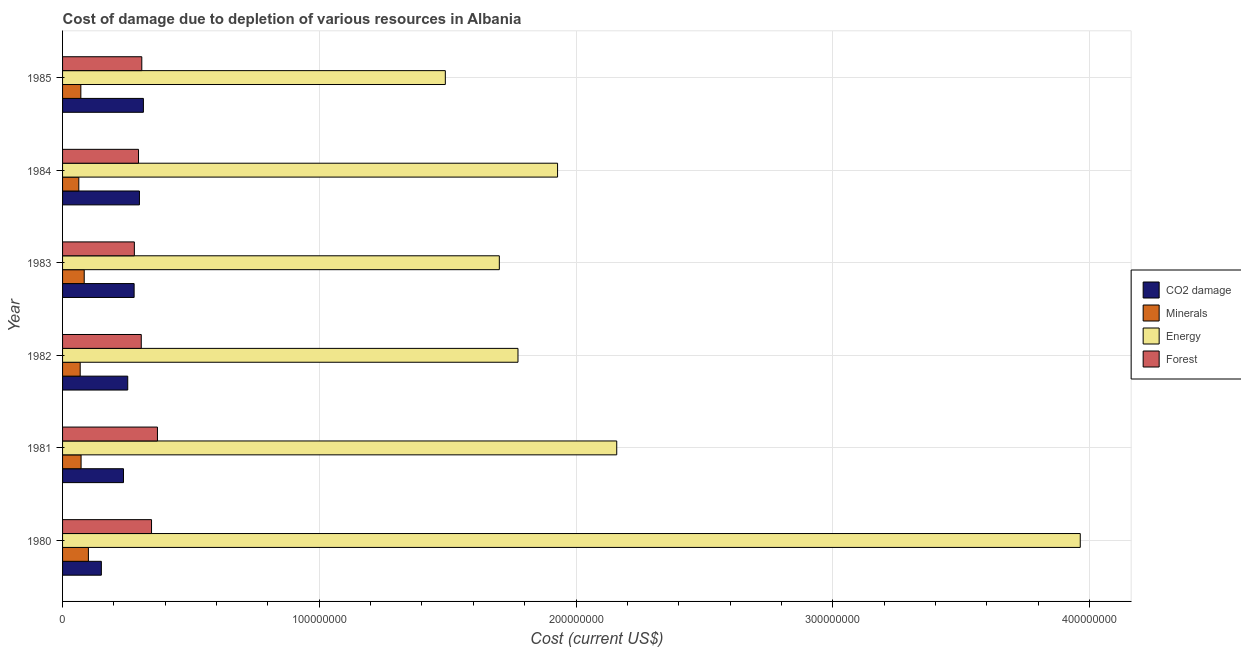Are the number of bars per tick equal to the number of legend labels?
Give a very brief answer. Yes. Are the number of bars on each tick of the Y-axis equal?
Give a very brief answer. Yes. In how many cases, is the number of bars for a given year not equal to the number of legend labels?
Give a very brief answer. 0. What is the cost of damage due to depletion of coal in 1981?
Ensure brevity in your answer.  2.37e+07. Across all years, what is the maximum cost of damage due to depletion of energy?
Keep it short and to the point. 3.96e+08. Across all years, what is the minimum cost of damage due to depletion of energy?
Provide a short and direct response. 1.49e+08. What is the total cost of damage due to depletion of energy in the graph?
Provide a succinct answer. 1.30e+09. What is the difference between the cost of damage due to depletion of forests in 1981 and that in 1985?
Provide a succinct answer. 6.10e+06. What is the difference between the cost of damage due to depletion of coal in 1980 and the cost of damage due to depletion of minerals in 1983?
Keep it short and to the point. 6.67e+06. What is the average cost of damage due to depletion of energy per year?
Your answer should be very brief. 2.17e+08. In the year 1982, what is the difference between the cost of damage due to depletion of coal and cost of damage due to depletion of forests?
Ensure brevity in your answer.  -5.27e+06. What is the ratio of the cost of damage due to depletion of minerals in 1980 to that in 1984?
Offer a terse response. 1.59. What is the difference between the highest and the second highest cost of damage due to depletion of coal?
Your answer should be compact. 1.54e+06. What is the difference between the highest and the lowest cost of damage due to depletion of energy?
Make the answer very short. 2.47e+08. In how many years, is the cost of damage due to depletion of forests greater than the average cost of damage due to depletion of forests taken over all years?
Provide a short and direct response. 2. Is the sum of the cost of damage due to depletion of forests in 1980 and 1982 greater than the maximum cost of damage due to depletion of coal across all years?
Make the answer very short. Yes. What does the 1st bar from the top in 1985 represents?
Your response must be concise. Forest. What does the 3rd bar from the bottom in 1985 represents?
Offer a very short reply. Energy. How many years are there in the graph?
Provide a succinct answer. 6. Does the graph contain grids?
Offer a very short reply. Yes. Where does the legend appear in the graph?
Offer a terse response. Center right. What is the title of the graph?
Offer a terse response. Cost of damage due to depletion of various resources in Albania . What is the label or title of the X-axis?
Offer a terse response. Cost (current US$). What is the label or title of the Y-axis?
Your answer should be compact. Year. What is the Cost (current US$) in CO2 damage in 1980?
Your answer should be very brief. 1.51e+07. What is the Cost (current US$) of Minerals in 1980?
Keep it short and to the point. 1.01e+07. What is the Cost (current US$) in Energy in 1980?
Make the answer very short. 3.96e+08. What is the Cost (current US$) in Forest in 1980?
Your answer should be compact. 3.47e+07. What is the Cost (current US$) in CO2 damage in 1981?
Give a very brief answer. 2.37e+07. What is the Cost (current US$) in Minerals in 1981?
Ensure brevity in your answer.  7.21e+06. What is the Cost (current US$) of Energy in 1981?
Your answer should be compact. 2.16e+08. What is the Cost (current US$) in Forest in 1981?
Your response must be concise. 3.70e+07. What is the Cost (current US$) of CO2 damage in 1982?
Keep it short and to the point. 2.54e+07. What is the Cost (current US$) of Minerals in 1982?
Offer a terse response. 6.87e+06. What is the Cost (current US$) in Energy in 1982?
Your response must be concise. 1.77e+08. What is the Cost (current US$) in Forest in 1982?
Offer a terse response. 3.07e+07. What is the Cost (current US$) of CO2 damage in 1983?
Provide a succinct answer. 2.79e+07. What is the Cost (current US$) of Minerals in 1983?
Give a very brief answer. 8.43e+06. What is the Cost (current US$) in Energy in 1983?
Make the answer very short. 1.70e+08. What is the Cost (current US$) in Forest in 1983?
Make the answer very short. 2.80e+07. What is the Cost (current US$) in CO2 damage in 1984?
Offer a terse response. 2.99e+07. What is the Cost (current US$) in Minerals in 1984?
Your response must be concise. 6.33e+06. What is the Cost (current US$) of Energy in 1984?
Make the answer very short. 1.93e+08. What is the Cost (current US$) in Forest in 1984?
Give a very brief answer. 2.96e+07. What is the Cost (current US$) of CO2 damage in 1985?
Give a very brief answer. 3.15e+07. What is the Cost (current US$) of Minerals in 1985?
Your answer should be compact. 7.12e+06. What is the Cost (current US$) in Energy in 1985?
Offer a terse response. 1.49e+08. What is the Cost (current US$) in Forest in 1985?
Provide a succinct answer. 3.09e+07. Across all years, what is the maximum Cost (current US$) in CO2 damage?
Keep it short and to the point. 3.15e+07. Across all years, what is the maximum Cost (current US$) in Minerals?
Offer a terse response. 1.01e+07. Across all years, what is the maximum Cost (current US$) of Energy?
Your answer should be very brief. 3.96e+08. Across all years, what is the maximum Cost (current US$) in Forest?
Ensure brevity in your answer.  3.70e+07. Across all years, what is the minimum Cost (current US$) of CO2 damage?
Your answer should be compact. 1.51e+07. Across all years, what is the minimum Cost (current US$) of Minerals?
Provide a short and direct response. 6.33e+06. Across all years, what is the minimum Cost (current US$) of Energy?
Your answer should be very brief. 1.49e+08. Across all years, what is the minimum Cost (current US$) in Forest?
Provide a succinct answer. 2.80e+07. What is the total Cost (current US$) of CO2 damage in the graph?
Your answer should be compact. 1.54e+08. What is the total Cost (current US$) in Minerals in the graph?
Keep it short and to the point. 4.60e+07. What is the total Cost (current US$) in Energy in the graph?
Your response must be concise. 1.30e+09. What is the total Cost (current US$) in Forest in the graph?
Your response must be concise. 1.91e+08. What is the difference between the Cost (current US$) in CO2 damage in 1980 and that in 1981?
Provide a succinct answer. -8.62e+06. What is the difference between the Cost (current US$) in Minerals in 1980 and that in 1981?
Keep it short and to the point. 2.86e+06. What is the difference between the Cost (current US$) of Energy in 1980 and that in 1981?
Keep it short and to the point. 1.81e+08. What is the difference between the Cost (current US$) in Forest in 1980 and that in 1981?
Give a very brief answer. -2.31e+06. What is the difference between the Cost (current US$) in CO2 damage in 1980 and that in 1982?
Your answer should be very brief. -1.03e+07. What is the difference between the Cost (current US$) of Minerals in 1980 and that in 1982?
Make the answer very short. 3.20e+06. What is the difference between the Cost (current US$) of Energy in 1980 and that in 1982?
Your answer should be very brief. 2.19e+08. What is the difference between the Cost (current US$) of Forest in 1980 and that in 1982?
Your answer should be compact. 4.00e+06. What is the difference between the Cost (current US$) in CO2 damage in 1980 and that in 1983?
Provide a succinct answer. -1.28e+07. What is the difference between the Cost (current US$) in Minerals in 1980 and that in 1983?
Offer a very short reply. 1.63e+06. What is the difference between the Cost (current US$) in Energy in 1980 and that in 1983?
Keep it short and to the point. 2.26e+08. What is the difference between the Cost (current US$) of Forest in 1980 and that in 1983?
Offer a very short reply. 6.68e+06. What is the difference between the Cost (current US$) of CO2 damage in 1980 and that in 1984?
Your answer should be very brief. -1.48e+07. What is the difference between the Cost (current US$) in Minerals in 1980 and that in 1984?
Ensure brevity in your answer.  3.74e+06. What is the difference between the Cost (current US$) in Energy in 1980 and that in 1984?
Offer a terse response. 2.04e+08. What is the difference between the Cost (current US$) of Forest in 1980 and that in 1984?
Make the answer very short. 5.07e+06. What is the difference between the Cost (current US$) in CO2 damage in 1980 and that in 1985?
Provide a succinct answer. -1.64e+07. What is the difference between the Cost (current US$) of Minerals in 1980 and that in 1985?
Provide a short and direct response. 2.95e+06. What is the difference between the Cost (current US$) of Energy in 1980 and that in 1985?
Provide a succinct answer. 2.47e+08. What is the difference between the Cost (current US$) of Forest in 1980 and that in 1985?
Provide a succinct answer. 3.79e+06. What is the difference between the Cost (current US$) in CO2 damage in 1981 and that in 1982?
Your answer should be very brief. -1.65e+06. What is the difference between the Cost (current US$) of Minerals in 1981 and that in 1982?
Offer a terse response. 3.46e+05. What is the difference between the Cost (current US$) of Energy in 1981 and that in 1982?
Your response must be concise. 3.85e+07. What is the difference between the Cost (current US$) of Forest in 1981 and that in 1982?
Ensure brevity in your answer.  6.31e+06. What is the difference between the Cost (current US$) of CO2 damage in 1981 and that in 1983?
Your answer should be compact. -4.14e+06. What is the difference between the Cost (current US$) of Minerals in 1981 and that in 1983?
Offer a very short reply. -1.22e+06. What is the difference between the Cost (current US$) in Energy in 1981 and that in 1983?
Ensure brevity in your answer.  4.57e+07. What is the difference between the Cost (current US$) in Forest in 1981 and that in 1983?
Your answer should be compact. 9.00e+06. What is the difference between the Cost (current US$) in CO2 damage in 1981 and that in 1984?
Offer a very short reply. -6.22e+06. What is the difference between the Cost (current US$) of Minerals in 1981 and that in 1984?
Keep it short and to the point. 8.84e+05. What is the difference between the Cost (current US$) of Energy in 1981 and that in 1984?
Offer a terse response. 2.30e+07. What is the difference between the Cost (current US$) of Forest in 1981 and that in 1984?
Provide a succinct answer. 7.38e+06. What is the difference between the Cost (current US$) in CO2 damage in 1981 and that in 1985?
Provide a succinct answer. -7.76e+06. What is the difference between the Cost (current US$) in Minerals in 1981 and that in 1985?
Make the answer very short. 9.07e+04. What is the difference between the Cost (current US$) of Energy in 1981 and that in 1985?
Make the answer very short. 6.68e+07. What is the difference between the Cost (current US$) in Forest in 1981 and that in 1985?
Provide a succinct answer. 6.10e+06. What is the difference between the Cost (current US$) in CO2 damage in 1982 and that in 1983?
Make the answer very short. -2.49e+06. What is the difference between the Cost (current US$) of Minerals in 1982 and that in 1983?
Keep it short and to the point. -1.57e+06. What is the difference between the Cost (current US$) of Energy in 1982 and that in 1983?
Provide a succinct answer. 7.27e+06. What is the difference between the Cost (current US$) in Forest in 1982 and that in 1983?
Provide a short and direct response. 2.69e+06. What is the difference between the Cost (current US$) of CO2 damage in 1982 and that in 1984?
Your answer should be compact. -4.56e+06. What is the difference between the Cost (current US$) in Minerals in 1982 and that in 1984?
Provide a succinct answer. 5.38e+05. What is the difference between the Cost (current US$) of Energy in 1982 and that in 1984?
Your answer should be compact. -1.54e+07. What is the difference between the Cost (current US$) of Forest in 1982 and that in 1984?
Make the answer very short. 1.07e+06. What is the difference between the Cost (current US$) in CO2 damage in 1982 and that in 1985?
Provide a succinct answer. -6.10e+06. What is the difference between the Cost (current US$) in Minerals in 1982 and that in 1985?
Make the answer very short. -2.56e+05. What is the difference between the Cost (current US$) in Energy in 1982 and that in 1985?
Provide a short and direct response. 2.83e+07. What is the difference between the Cost (current US$) in Forest in 1982 and that in 1985?
Your answer should be compact. -2.09e+05. What is the difference between the Cost (current US$) of CO2 damage in 1983 and that in 1984?
Offer a terse response. -2.07e+06. What is the difference between the Cost (current US$) in Minerals in 1983 and that in 1984?
Your answer should be compact. 2.11e+06. What is the difference between the Cost (current US$) in Energy in 1983 and that in 1984?
Offer a very short reply. -2.27e+07. What is the difference between the Cost (current US$) in Forest in 1983 and that in 1984?
Offer a terse response. -1.62e+06. What is the difference between the Cost (current US$) in CO2 damage in 1983 and that in 1985?
Ensure brevity in your answer.  -3.61e+06. What is the difference between the Cost (current US$) of Minerals in 1983 and that in 1985?
Ensure brevity in your answer.  1.31e+06. What is the difference between the Cost (current US$) of Energy in 1983 and that in 1985?
Offer a terse response. 2.10e+07. What is the difference between the Cost (current US$) of Forest in 1983 and that in 1985?
Provide a short and direct response. -2.90e+06. What is the difference between the Cost (current US$) of CO2 damage in 1984 and that in 1985?
Your answer should be very brief. -1.54e+06. What is the difference between the Cost (current US$) of Minerals in 1984 and that in 1985?
Your answer should be very brief. -7.93e+05. What is the difference between the Cost (current US$) of Energy in 1984 and that in 1985?
Make the answer very short. 4.37e+07. What is the difference between the Cost (current US$) in Forest in 1984 and that in 1985?
Offer a very short reply. -1.28e+06. What is the difference between the Cost (current US$) in CO2 damage in 1980 and the Cost (current US$) in Minerals in 1981?
Make the answer very short. 7.90e+06. What is the difference between the Cost (current US$) of CO2 damage in 1980 and the Cost (current US$) of Energy in 1981?
Provide a succinct answer. -2.01e+08. What is the difference between the Cost (current US$) of CO2 damage in 1980 and the Cost (current US$) of Forest in 1981?
Your response must be concise. -2.19e+07. What is the difference between the Cost (current US$) of Minerals in 1980 and the Cost (current US$) of Energy in 1981?
Your answer should be very brief. -2.06e+08. What is the difference between the Cost (current US$) in Minerals in 1980 and the Cost (current US$) in Forest in 1981?
Provide a succinct answer. -2.69e+07. What is the difference between the Cost (current US$) in Energy in 1980 and the Cost (current US$) in Forest in 1981?
Provide a short and direct response. 3.59e+08. What is the difference between the Cost (current US$) of CO2 damage in 1980 and the Cost (current US$) of Minerals in 1982?
Your response must be concise. 8.24e+06. What is the difference between the Cost (current US$) in CO2 damage in 1980 and the Cost (current US$) in Energy in 1982?
Make the answer very short. -1.62e+08. What is the difference between the Cost (current US$) in CO2 damage in 1980 and the Cost (current US$) in Forest in 1982?
Provide a succinct answer. -1.55e+07. What is the difference between the Cost (current US$) of Minerals in 1980 and the Cost (current US$) of Energy in 1982?
Provide a succinct answer. -1.67e+08. What is the difference between the Cost (current US$) of Minerals in 1980 and the Cost (current US$) of Forest in 1982?
Your answer should be compact. -2.06e+07. What is the difference between the Cost (current US$) in Energy in 1980 and the Cost (current US$) in Forest in 1982?
Your answer should be compact. 3.66e+08. What is the difference between the Cost (current US$) in CO2 damage in 1980 and the Cost (current US$) in Minerals in 1983?
Offer a very short reply. 6.67e+06. What is the difference between the Cost (current US$) of CO2 damage in 1980 and the Cost (current US$) of Energy in 1983?
Give a very brief answer. -1.55e+08. What is the difference between the Cost (current US$) of CO2 damage in 1980 and the Cost (current US$) of Forest in 1983?
Give a very brief answer. -1.29e+07. What is the difference between the Cost (current US$) in Minerals in 1980 and the Cost (current US$) in Energy in 1983?
Offer a terse response. -1.60e+08. What is the difference between the Cost (current US$) of Minerals in 1980 and the Cost (current US$) of Forest in 1983?
Offer a terse response. -1.79e+07. What is the difference between the Cost (current US$) of Energy in 1980 and the Cost (current US$) of Forest in 1983?
Provide a short and direct response. 3.68e+08. What is the difference between the Cost (current US$) of CO2 damage in 1980 and the Cost (current US$) of Minerals in 1984?
Ensure brevity in your answer.  8.78e+06. What is the difference between the Cost (current US$) in CO2 damage in 1980 and the Cost (current US$) in Energy in 1984?
Give a very brief answer. -1.78e+08. What is the difference between the Cost (current US$) in CO2 damage in 1980 and the Cost (current US$) in Forest in 1984?
Your answer should be very brief. -1.45e+07. What is the difference between the Cost (current US$) of Minerals in 1980 and the Cost (current US$) of Energy in 1984?
Give a very brief answer. -1.83e+08. What is the difference between the Cost (current US$) in Minerals in 1980 and the Cost (current US$) in Forest in 1984?
Your response must be concise. -1.95e+07. What is the difference between the Cost (current US$) in Energy in 1980 and the Cost (current US$) in Forest in 1984?
Keep it short and to the point. 3.67e+08. What is the difference between the Cost (current US$) of CO2 damage in 1980 and the Cost (current US$) of Minerals in 1985?
Make the answer very short. 7.99e+06. What is the difference between the Cost (current US$) of CO2 damage in 1980 and the Cost (current US$) of Energy in 1985?
Give a very brief answer. -1.34e+08. What is the difference between the Cost (current US$) in CO2 damage in 1980 and the Cost (current US$) in Forest in 1985?
Offer a very short reply. -1.58e+07. What is the difference between the Cost (current US$) of Minerals in 1980 and the Cost (current US$) of Energy in 1985?
Make the answer very short. -1.39e+08. What is the difference between the Cost (current US$) of Minerals in 1980 and the Cost (current US$) of Forest in 1985?
Offer a very short reply. -2.08e+07. What is the difference between the Cost (current US$) in Energy in 1980 and the Cost (current US$) in Forest in 1985?
Offer a terse response. 3.66e+08. What is the difference between the Cost (current US$) of CO2 damage in 1981 and the Cost (current US$) of Minerals in 1982?
Make the answer very short. 1.69e+07. What is the difference between the Cost (current US$) in CO2 damage in 1981 and the Cost (current US$) in Energy in 1982?
Give a very brief answer. -1.54e+08. What is the difference between the Cost (current US$) in CO2 damage in 1981 and the Cost (current US$) in Forest in 1982?
Give a very brief answer. -6.93e+06. What is the difference between the Cost (current US$) in Minerals in 1981 and the Cost (current US$) in Energy in 1982?
Your response must be concise. -1.70e+08. What is the difference between the Cost (current US$) in Minerals in 1981 and the Cost (current US$) in Forest in 1982?
Your answer should be very brief. -2.34e+07. What is the difference between the Cost (current US$) in Energy in 1981 and the Cost (current US$) in Forest in 1982?
Offer a very short reply. 1.85e+08. What is the difference between the Cost (current US$) of CO2 damage in 1981 and the Cost (current US$) of Minerals in 1983?
Make the answer very short. 1.53e+07. What is the difference between the Cost (current US$) in CO2 damage in 1981 and the Cost (current US$) in Energy in 1983?
Your response must be concise. -1.46e+08. What is the difference between the Cost (current US$) in CO2 damage in 1981 and the Cost (current US$) in Forest in 1983?
Your answer should be compact. -4.24e+06. What is the difference between the Cost (current US$) in Minerals in 1981 and the Cost (current US$) in Energy in 1983?
Keep it short and to the point. -1.63e+08. What is the difference between the Cost (current US$) of Minerals in 1981 and the Cost (current US$) of Forest in 1983?
Keep it short and to the point. -2.08e+07. What is the difference between the Cost (current US$) in Energy in 1981 and the Cost (current US$) in Forest in 1983?
Provide a succinct answer. 1.88e+08. What is the difference between the Cost (current US$) of CO2 damage in 1981 and the Cost (current US$) of Minerals in 1984?
Your response must be concise. 1.74e+07. What is the difference between the Cost (current US$) of CO2 damage in 1981 and the Cost (current US$) of Energy in 1984?
Provide a short and direct response. -1.69e+08. What is the difference between the Cost (current US$) of CO2 damage in 1981 and the Cost (current US$) of Forest in 1984?
Your answer should be compact. -5.85e+06. What is the difference between the Cost (current US$) of Minerals in 1981 and the Cost (current US$) of Energy in 1984?
Provide a succinct answer. -1.86e+08. What is the difference between the Cost (current US$) of Minerals in 1981 and the Cost (current US$) of Forest in 1984?
Ensure brevity in your answer.  -2.24e+07. What is the difference between the Cost (current US$) in Energy in 1981 and the Cost (current US$) in Forest in 1984?
Make the answer very short. 1.86e+08. What is the difference between the Cost (current US$) of CO2 damage in 1981 and the Cost (current US$) of Minerals in 1985?
Make the answer very short. 1.66e+07. What is the difference between the Cost (current US$) in CO2 damage in 1981 and the Cost (current US$) in Energy in 1985?
Give a very brief answer. -1.25e+08. What is the difference between the Cost (current US$) of CO2 damage in 1981 and the Cost (current US$) of Forest in 1985?
Your response must be concise. -7.14e+06. What is the difference between the Cost (current US$) in Minerals in 1981 and the Cost (current US$) in Energy in 1985?
Offer a very short reply. -1.42e+08. What is the difference between the Cost (current US$) in Minerals in 1981 and the Cost (current US$) in Forest in 1985?
Your answer should be very brief. -2.37e+07. What is the difference between the Cost (current US$) of Energy in 1981 and the Cost (current US$) of Forest in 1985?
Offer a terse response. 1.85e+08. What is the difference between the Cost (current US$) in CO2 damage in 1982 and the Cost (current US$) in Minerals in 1983?
Make the answer very short. 1.69e+07. What is the difference between the Cost (current US$) of CO2 damage in 1982 and the Cost (current US$) of Energy in 1983?
Give a very brief answer. -1.45e+08. What is the difference between the Cost (current US$) in CO2 damage in 1982 and the Cost (current US$) in Forest in 1983?
Make the answer very short. -2.58e+06. What is the difference between the Cost (current US$) of Minerals in 1982 and the Cost (current US$) of Energy in 1983?
Keep it short and to the point. -1.63e+08. What is the difference between the Cost (current US$) in Minerals in 1982 and the Cost (current US$) in Forest in 1983?
Your answer should be compact. -2.11e+07. What is the difference between the Cost (current US$) in Energy in 1982 and the Cost (current US$) in Forest in 1983?
Provide a short and direct response. 1.49e+08. What is the difference between the Cost (current US$) of CO2 damage in 1982 and the Cost (current US$) of Minerals in 1984?
Provide a succinct answer. 1.91e+07. What is the difference between the Cost (current US$) in CO2 damage in 1982 and the Cost (current US$) in Energy in 1984?
Keep it short and to the point. -1.67e+08. What is the difference between the Cost (current US$) in CO2 damage in 1982 and the Cost (current US$) in Forest in 1984?
Your response must be concise. -4.20e+06. What is the difference between the Cost (current US$) of Minerals in 1982 and the Cost (current US$) of Energy in 1984?
Your response must be concise. -1.86e+08. What is the difference between the Cost (current US$) in Minerals in 1982 and the Cost (current US$) in Forest in 1984?
Your response must be concise. -2.27e+07. What is the difference between the Cost (current US$) in Energy in 1982 and the Cost (current US$) in Forest in 1984?
Ensure brevity in your answer.  1.48e+08. What is the difference between the Cost (current US$) in CO2 damage in 1982 and the Cost (current US$) in Minerals in 1985?
Offer a terse response. 1.83e+07. What is the difference between the Cost (current US$) of CO2 damage in 1982 and the Cost (current US$) of Energy in 1985?
Your answer should be compact. -1.24e+08. What is the difference between the Cost (current US$) in CO2 damage in 1982 and the Cost (current US$) in Forest in 1985?
Offer a very short reply. -5.48e+06. What is the difference between the Cost (current US$) in Minerals in 1982 and the Cost (current US$) in Energy in 1985?
Provide a succinct answer. -1.42e+08. What is the difference between the Cost (current US$) of Minerals in 1982 and the Cost (current US$) of Forest in 1985?
Offer a very short reply. -2.40e+07. What is the difference between the Cost (current US$) in Energy in 1982 and the Cost (current US$) in Forest in 1985?
Offer a terse response. 1.47e+08. What is the difference between the Cost (current US$) of CO2 damage in 1983 and the Cost (current US$) of Minerals in 1984?
Your answer should be very brief. 2.15e+07. What is the difference between the Cost (current US$) in CO2 damage in 1983 and the Cost (current US$) in Energy in 1984?
Ensure brevity in your answer.  -1.65e+08. What is the difference between the Cost (current US$) of CO2 damage in 1983 and the Cost (current US$) of Forest in 1984?
Your answer should be compact. -1.71e+06. What is the difference between the Cost (current US$) in Minerals in 1983 and the Cost (current US$) in Energy in 1984?
Offer a very short reply. -1.84e+08. What is the difference between the Cost (current US$) of Minerals in 1983 and the Cost (current US$) of Forest in 1984?
Your answer should be very brief. -2.11e+07. What is the difference between the Cost (current US$) of Energy in 1983 and the Cost (current US$) of Forest in 1984?
Give a very brief answer. 1.41e+08. What is the difference between the Cost (current US$) of CO2 damage in 1983 and the Cost (current US$) of Minerals in 1985?
Offer a very short reply. 2.08e+07. What is the difference between the Cost (current US$) in CO2 damage in 1983 and the Cost (current US$) in Energy in 1985?
Offer a very short reply. -1.21e+08. What is the difference between the Cost (current US$) in CO2 damage in 1983 and the Cost (current US$) in Forest in 1985?
Provide a short and direct response. -2.99e+06. What is the difference between the Cost (current US$) in Minerals in 1983 and the Cost (current US$) in Energy in 1985?
Offer a very short reply. -1.41e+08. What is the difference between the Cost (current US$) of Minerals in 1983 and the Cost (current US$) of Forest in 1985?
Your response must be concise. -2.24e+07. What is the difference between the Cost (current US$) of Energy in 1983 and the Cost (current US$) of Forest in 1985?
Offer a very short reply. 1.39e+08. What is the difference between the Cost (current US$) in CO2 damage in 1984 and the Cost (current US$) in Minerals in 1985?
Your response must be concise. 2.28e+07. What is the difference between the Cost (current US$) of CO2 damage in 1984 and the Cost (current US$) of Energy in 1985?
Provide a short and direct response. -1.19e+08. What is the difference between the Cost (current US$) in CO2 damage in 1984 and the Cost (current US$) in Forest in 1985?
Your response must be concise. -9.19e+05. What is the difference between the Cost (current US$) in Minerals in 1984 and the Cost (current US$) in Energy in 1985?
Your answer should be compact. -1.43e+08. What is the difference between the Cost (current US$) in Minerals in 1984 and the Cost (current US$) in Forest in 1985?
Your answer should be compact. -2.45e+07. What is the difference between the Cost (current US$) in Energy in 1984 and the Cost (current US$) in Forest in 1985?
Offer a very short reply. 1.62e+08. What is the average Cost (current US$) of CO2 damage per year?
Your answer should be compact. 2.56e+07. What is the average Cost (current US$) of Minerals per year?
Give a very brief answer. 7.67e+06. What is the average Cost (current US$) of Energy per year?
Your response must be concise. 2.17e+08. What is the average Cost (current US$) in Forest per year?
Offer a terse response. 3.18e+07. In the year 1980, what is the difference between the Cost (current US$) of CO2 damage and Cost (current US$) of Minerals?
Ensure brevity in your answer.  5.04e+06. In the year 1980, what is the difference between the Cost (current US$) in CO2 damage and Cost (current US$) in Energy?
Offer a terse response. -3.81e+08. In the year 1980, what is the difference between the Cost (current US$) of CO2 damage and Cost (current US$) of Forest?
Give a very brief answer. -1.95e+07. In the year 1980, what is the difference between the Cost (current US$) in Minerals and Cost (current US$) in Energy?
Make the answer very short. -3.86e+08. In the year 1980, what is the difference between the Cost (current US$) in Minerals and Cost (current US$) in Forest?
Give a very brief answer. -2.46e+07. In the year 1980, what is the difference between the Cost (current US$) of Energy and Cost (current US$) of Forest?
Your answer should be very brief. 3.62e+08. In the year 1981, what is the difference between the Cost (current US$) of CO2 damage and Cost (current US$) of Minerals?
Your response must be concise. 1.65e+07. In the year 1981, what is the difference between the Cost (current US$) of CO2 damage and Cost (current US$) of Energy?
Provide a short and direct response. -1.92e+08. In the year 1981, what is the difference between the Cost (current US$) of CO2 damage and Cost (current US$) of Forest?
Your answer should be very brief. -1.32e+07. In the year 1981, what is the difference between the Cost (current US$) of Minerals and Cost (current US$) of Energy?
Give a very brief answer. -2.09e+08. In the year 1981, what is the difference between the Cost (current US$) in Minerals and Cost (current US$) in Forest?
Ensure brevity in your answer.  -2.97e+07. In the year 1981, what is the difference between the Cost (current US$) in Energy and Cost (current US$) in Forest?
Ensure brevity in your answer.  1.79e+08. In the year 1982, what is the difference between the Cost (current US$) in CO2 damage and Cost (current US$) in Minerals?
Give a very brief answer. 1.85e+07. In the year 1982, what is the difference between the Cost (current US$) in CO2 damage and Cost (current US$) in Energy?
Make the answer very short. -1.52e+08. In the year 1982, what is the difference between the Cost (current US$) in CO2 damage and Cost (current US$) in Forest?
Offer a very short reply. -5.27e+06. In the year 1982, what is the difference between the Cost (current US$) in Minerals and Cost (current US$) in Energy?
Your answer should be very brief. -1.71e+08. In the year 1982, what is the difference between the Cost (current US$) of Minerals and Cost (current US$) of Forest?
Offer a very short reply. -2.38e+07. In the year 1982, what is the difference between the Cost (current US$) in Energy and Cost (current US$) in Forest?
Offer a terse response. 1.47e+08. In the year 1983, what is the difference between the Cost (current US$) of CO2 damage and Cost (current US$) of Minerals?
Your answer should be compact. 1.94e+07. In the year 1983, what is the difference between the Cost (current US$) of CO2 damage and Cost (current US$) of Energy?
Your answer should be compact. -1.42e+08. In the year 1983, what is the difference between the Cost (current US$) in CO2 damage and Cost (current US$) in Forest?
Offer a very short reply. -9.24e+04. In the year 1983, what is the difference between the Cost (current US$) of Minerals and Cost (current US$) of Energy?
Your response must be concise. -1.62e+08. In the year 1983, what is the difference between the Cost (current US$) of Minerals and Cost (current US$) of Forest?
Your response must be concise. -1.95e+07. In the year 1983, what is the difference between the Cost (current US$) of Energy and Cost (current US$) of Forest?
Your answer should be very brief. 1.42e+08. In the year 1984, what is the difference between the Cost (current US$) of CO2 damage and Cost (current US$) of Minerals?
Make the answer very short. 2.36e+07. In the year 1984, what is the difference between the Cost (current US$) of CO2 damage and Cost (current US$) of Energy?
Keep it short and to the point. -1.63e+08. In the year 1984, what is the difference between the Cost (current US$) of CO2 damage and Cost (current US$) of Forest?
Your response must be concise. 3.64e+05. In the year 1984, what is the difference between the Cost (current US$) of Minerals and Cost (current US$) of Energy?
Keep it short and to the point. -1.86e+08. In the year 1984, what is the difference between the Cost (current US$) in Minerals and Cost (current US$) in Forest?
Make the answer very short. -2.33e+07. In the year 1984, what is the difference between the Cost (current US$) in Energy and Cost (current US$) in Forest?
Your answer should be very brief. 1.63e+08. In the year 1985, what is the difference between the Cost (current US$) in CO2 damage and Cost (current US$) in Minerals?
Your answer should be compact. 2.44e+07. In the year 1985, what is the difference between the Cost (current US$) in CO2 damage and Cost (current US$) in Energy?
Ensure brevity in your answer.  -1.18e+08. In the year 1985, what is the difference between the Cost (current US$) of CO2 damage and Cost (current US$) of Forest?
Keep it short and to the point. 6.22e+05. In the year 1985, what is the difference between the Cost (current US$) in Minerals and Cost (current US$) in Energy?
Your response must be concise. -1.42e+08. In the year 1985, what is the difference between the Cost (current US$) of Minerals and Cost (current US$) of Forest?
Make the answer very short. -2.37e+07. In the year 1985, what is the difference between the Cost (current US$) of Energy and Cost (current US$) of Forest?
Your response must be concise. 1.18e+08. What is the ratio of the Cost (current US$) in CO2 damage in 1980 to that in 1981?
Provide a short and direct response. 0.64. What is the ratio of the Cost (current US$) of Minerals in 1980 to that in 1981?
Make the answer very short. 1.4. What is the ratio of the Cost (current US$) in Energy in 1980 to that in 1981?
Offer a very short reply. 1.84. What is the ratio of the Cost (current US$) in CO2 damage in 1980 to that in 1982?
Provide a short and direct response. 0.6. What is the ratio of the Cost (current US$) in Minerals in 1980 to that in 1982?
Ensure brevity in your answer.  1.47. What is the ratio of the Cost (current US$) in Energy in 1980 to that in 1982?
Ensure brevity in your answer.  2.23. What is the ratio of the Cost (current US$) in Forest in 1980 to that in 1982?
Make the answer very short. 1.13. What is the ratio of the Cost (current US$) of CO2 damage in 1980 to that in 1983?
Ensure brevity in your answer.  0.54. What is the ratio of the Cost (current US$) of Minerals in 1980 to that in 1983?
Keep it short and to the point. 1.19. What is the ratio of the Cost (current US$) of Energy in 1980 to that in 1983?
Make the answer very short. 2.33. What is the ratio of the Cost (current US$) in Forest in 1980 to that in 1983?
Your answer should be compact. 1.24. What is the ratio of the Cost (current US$) in CO2 damage in 1980 to that in 1984?
Keep it short and to the point. 0.5. What is the ratio of the Cost (current US$) in Minerals in 1980 to that in 1984?
Make the answer very short. 1.59. What is the ratio of the Cost (current US$) of Energy in 1980 to that in 1984?
Ensure brevity in your answer.  2.06. What is the ratio of the Cost (current US$) in Forest in 1980 to that in 1984?
Offer a very short reply. 1.17. What is the ratio of the Cost (current US$) in CO2 damage in 1980 to that in 1985?
Your response must be concise. 0.48. What is the ratio of the Cost (current US$) of Minerals in 1980 to that in 1985?
Make the answer very short. 1.41. What is the ratio of the Cost (current US$) of Energy in 1980 to that in 1985?
Give a very brief answer. 2.66. What is the ratio of the Cost (current US$) of Forest in 1980 to that in 1985?
Offer a terse response. 1.12. What is the ratio of the Cost (current US$) in CO2 damage in 1981 to that in 1982?
Your answer should be very brief. 0.93. What is the ratio of the Cost (current US$) in Minerals in 1981 to that in 1982?
Your response must be concise. 1.05. What is the ratio of the Cost (current US$) in Energy in 1981 to that in 1982?
Your answer should be very brief. 1.22. What is the ratio of the Cost (current US$) in Forest in 1981 to that in 1982?
Your answer should be very brief. 1.21. What is the ratio of the Cost (current US$) of CO2 damage in 1981 to that in 1983?
Your answer should be compact. 0.85. What is the ratio of the Cost (current US$) in Minerals in 1981 to that in 1983?
Your answer should be very brief. 0.86. What is the ratio of the Cost (current US$) of Energy in 1981 to that in 1983?
Keep it short and to the point. 1.27. What is the ratio of the Cost (current US$) of Forest in 1981 to that in 1983?
Ensure brevity in your answer.  1.32. What is the ratio of the Cost (current US$) of CO2 damage in 1981 to that in 1984?
Your answer should be compact. 0.79. What is the ratio of the Cost (current US$) of Minerals in 1981 to that in 1984?
Make the answer very short. 1.14. What is the ratio of the Cost (current US$) of Energy in 1981 to that in 1984?
Give a very brief answer. 1.12. What is the ratio of the Cost (current US$) in Forest in 1981 to that in 1984?
Keep it short and to the point. 1.25. What is the ratio of the Cost (current US$) of CO2 damage in 1981 to that in 1985?
Provide a short and direct response. 0.75. What is the ratio of the Cost (current US$) of Minerals in 1981 to that in 1985?
Offer a very short reply. 1.01. What is the ratio of the Cost (current US$) of Energy in 1981 to that in 1985?
Your answer should be compact. 1.45. What is the ratio of the Cost (current US$) in Forest in 1981 to that in 1985?
Keep it short and to the point. 1.2. What is the ratio of the Cost (current US$) in CO2 damage in 1982 to that in 1983?
Keep it short and to the point. 0.91. What is the ratio of the Cost (current US$) in Minerals in 1982 to that in 1983?
Ensure brevity in your answer.  0.81. What is the ratio of the Cost (current US$) in Energy in 1982 to that in 1983?
Provide a succinct answer. 1.04. What is the ratio of the Cost (current US$) in Forest in 1982 to that in 1983?
Your answer should be very brief. 1.1. What is the ratio of the Cost (current US$) in CO2 damage in 1982 to that in 1984?
Ensure brevity in your answer.  0.85. What is the ratio of the Cost (current US$) of Minerals in 1982 to that in 1984?
Give a very brief answer. 1.08. What is the ratio of the Cost (current US$) in Energy in 1982 to that in 1984?
Provide a succinct answer. 0.92. What is the ratio of the Cost (current US$) in Forest in 1982 to that in 1984?
Ensure brevity in your answer.  1.04. What is the ratio of the Cost (current US$) in CO2 damage in 1982 to that in 1985?
Give a very brief answer. 0.81. What is the ratio of the Cost (current US$) in Minerals in 1982 to that in 1985?
Your answer should be compact. 0.96. What is the ratio of the Cost (current US$) of Energy in 1982 to that in 1985?
Offer a terse response. 1.19. What is the ratio of the Cost (current US$) in Forest in 1982 to that in 1985?
Your response must be concise. 0.99. What is the ratio of the Cost (current US$) of CO2 damage in 1983 to that in 1984?
Offer a terse response. 0.93. What is the ratio of the Cost (current US$) in Minerals in 1983 to that in 1984?
Provide a succinct answer. 1.33. What is the ratio of the Cost (current US$) in Energy in 1983 to that in 1984?
Ensure brevity in your answer.  0.88. What is the ratio of the Cost (current US$) in Forest in 1983 to that in 1984?
Keep it short and to the point. 0.95. What is the ratio of the Cost (current US$) of CO2 damage in 1983 to that in 1985?
Make the answer very short. 0.89. What is the ratio of the Cost (current US$) of Minerals in 1983 to that in 1985?
Give a very brief answer. 1.18. What is the ratio of the Cost (current US$) of Energy in 1983 to that in 1985?
Give a very brief answer. 1.14. What is the ratio of the Cost (current US$) in Forest in 1983 to that in 1985?
Ensure brevity in your answer.  0.91. What is the ratio of the Cost (current US$) of CO2 damage in 1984 to that in 1985?
Keep it short and to the point. 0.95. What is the ratio of the Cost (current US$) of Minerals in 1984 to that in 1985?
Your response must be concise. 0.89. What is the ratio of the Cost (current US$) of Energy in 1984 to that in 1985?
Provide a succinct answer. 1.29. What is the ratio of the Cost (current US$) of Forest in 1984 to that in 1985?
Keep it short and to the point. 0.96. What is the difference between the highest and the second highest Cost (current US$) of CO2 damage?
Your answer should be compact. 1.54e+06. What is the difference between the highest and the second highest Cost (current US$) of Minerals?
Offer a terse response. 1.63e+06. What is the difference between the highest and the second highest Cost (current US$) of Energy?
Give a very brief answer. 1.81e+08. What is the difference between the highest and the second highest Cost (current US$) in Forest?
Ensure brevity in your answer.  2.31e+06. What is the difference between the highest and the lowest Cost (current US$) in CO2 damage?
Offer a terse response. 1.64e+07. What is the difference between the highest and the lowest Cost (current US$) in Minerals?
Offer a terse response. 3.74e+06. What is the difference between the highest and the lowest Cost (current US$) of Energy?
Offer a very short reply. 2.47e+08. What is the difference between the highest and the lowest Cost (current US$) in Forest?
Provide a short and direct response. 9.00e+06. 